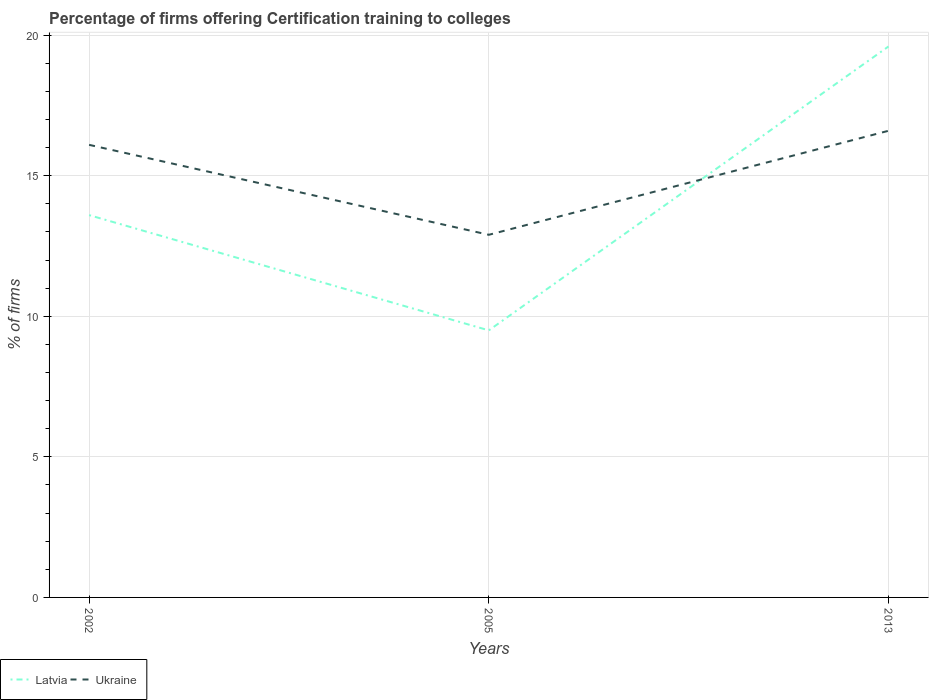Across all years, what is the maximum percentage of firms offering certification training to colleges in Ukraine?
Make the answer very short. 12.9. In which year was the percentage of firms offering certification training to colleges in Ukraine maximum?
Make the answer very short. 2005. What is the total percentage of firms offering certification training to colleges in Ukraine in the graph?
Your answer should be very brief. -0.5. What is the difference between the highest and the second highest percentage of firms offering certification training to colleges in Latvia?
Provide a short and direct response. 10.1. Is the percentage of firms offering certification training to colleges in Ukraine strictly greater than the percentage of firms offering certification training to colleges in Latvia over the years?
Your answer should be very brief. No. How many years are there in the graph?
Keep it short and to the point. 3. What is the difference between two consecutive major ticks on the Y-axis?
Ensure brevity in your answer.  5. Are the values on the major ticks of Y-axis written in scientific E-notation?
Offer a very short reply. No. Does the graph contain grids?
Your response must be concise. Yes. Where does the legend appear in the graph?
Provide a succinct answer. Bottom left. What is the title of the graph?
Provide a short and direct response. Percentage of firms offering Certification training to colleges. Does "Kosovo" appear as one of the legend labels in the graph?
Make the answer very short. No. What is the label or title of the Y-axis?
Your response must be concise. % of firms. What is the % of firms in Ukraine in 2002?
Give a very brief answer. 16.1. What is the % of firms of Latvia in 2005?
Offer a terse response. 9.5. What is the % of firms in Latvia in 2013?
Give a very brief answer. 19.6. What is the % of firms of Ukraine in 2013?
Make the answer very short. 16.6. Across all years, what is the maximum % of firms of Latvia?
Ensure brevity in your answer.  19.6. Across all years, what is the minimum % of firms of Ukraine?
Offer a very short reply. 12.9. What is the total % of firms in Latvia in the graph?
Give a very brief answer. 42.7. What is the total % of firms in Ukraine in the graph?
Offer a very short reply. 45.6. What is the difference between the % of firms in Ukraine in 2002 and that in 2005?
Make the answer very short. 3.2. What is the difference between the % of firms of Latvia in 2002 and that in 2013?
Your response must be concise. -6. What is the difference between the % of firms of Latvia in 2005 and that in 2013?
Provide a short and direct response. -10.1. What is the difference between the % of firms in Ukraine in 2005 and that in 2013?
Provide a succinct answer. -3.7. What is the difference between the % of firms of Latvia in 2002 and the % of firms of Ukraine in 2013?
Make the answer very short. -3. What is the average % of firms of Latvia per year?
Offer a very short reply. 14.23. In the year 2013, what is the difference between the % of firms of Latvia and % of firms of Ukraine?
Your answer should be very brief. 3. What is the ratio of the % of firms in Latvia in 2002 to that in 2005?
Keep it short and to the point. 1.43. What is the ratio of the % of firms of Ukraine in 2002 to that in 2005?
Your response must be concise. 1.25. What is the ratio of the % of firms of Latvia in 2002 to that in 2013?
Provide a short and direct response. 0.69. What is the ratio of the % of firms of Ukraine in 2002 to that in 2013?
Ensure brevity in your answer.  0.97. What is the ratio of the % of firms of Latvia in 2005 to that in 2013?
Ensure brevity in your answer.  0.48. What is the ratio of the % of firms of Ukraine in 2005 to that in 2013?
Keep it short and to the point. 0.78. What is the difference between the highest and the lowest % of firms in Latvia?
Your answer should be very brief. 10.1. What is the difference between the highest and the lowest % of firms of Ukraine?
Make the answer very short. 3.7. 